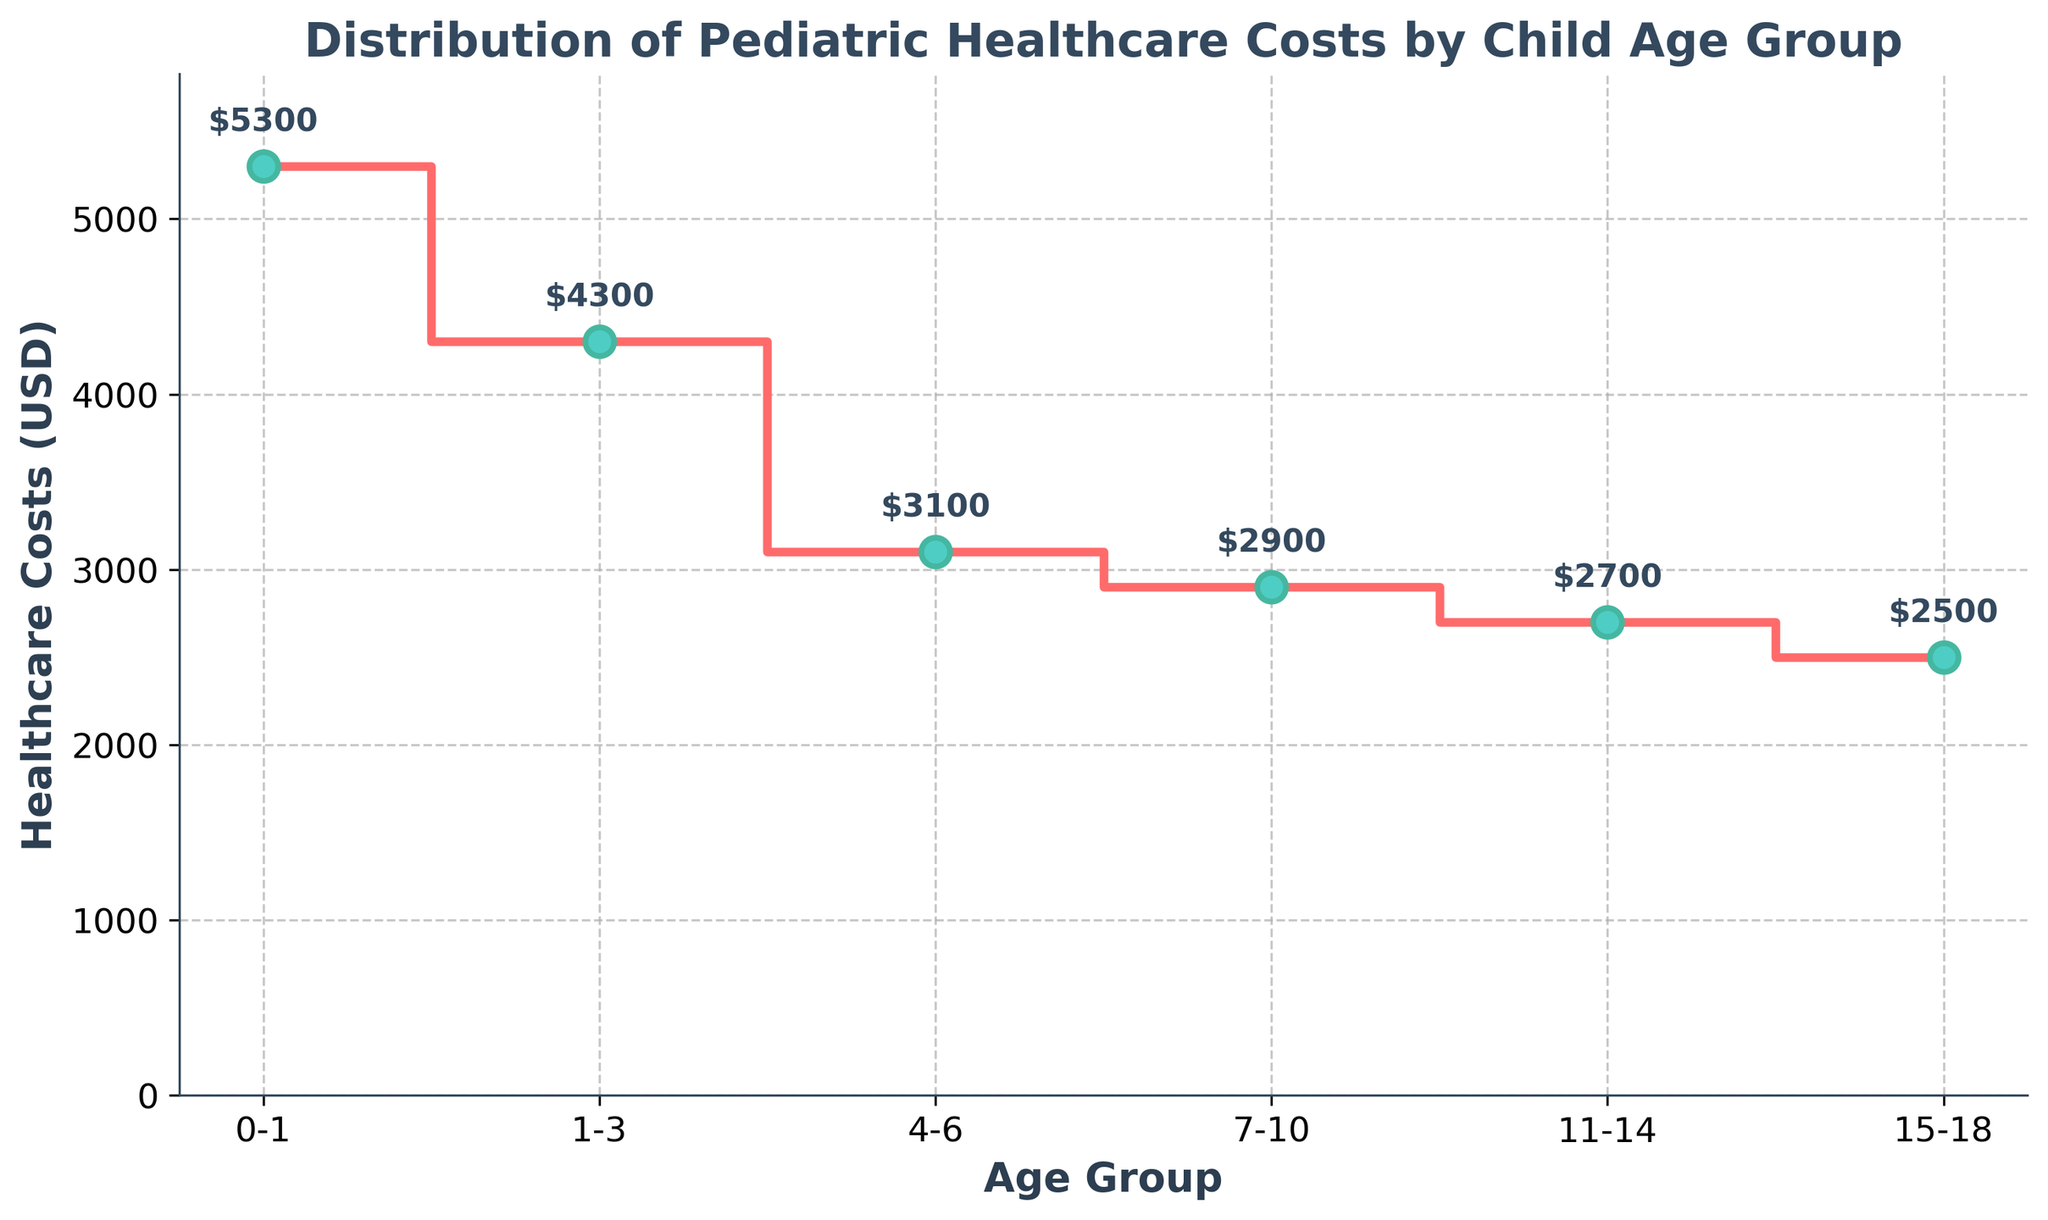What is the title of the plot? The title of the plot appears at the top and provides a concise description of what the plot represents.
Answer: Distribution of Pediatric Healthcare Costs by Child Age Group Which age group has the highest healthcare costs? The highest point on the y-axis that corresponds to an age group on the x-axis indicates the age group with the highest healthcare costs.
Answer: 0-1 What is the healthcare cost for the age group 7-10? Locate the age group 7-10 on the x-axis and trace the corresponding healthcare cost value on the y-axis.
Answer: 2900 How are the healthcare costs between the age groups 1-3 and 15-18 different? Subtract the healthcare cost of the age group 15-18 from the cost of the age group 1-3.
Answer: 1800 What is the average healthcare cost for all the age groups? Sum all the healthcare costs and then divide by the number of age groups, (5300 + 4300 + 3100 + 2900 + 2700 + 2500) / 6.
Answer: 3467 Which age group has the lowest healthcare costs? The lowest point on the y-axis that corresponds to an age group on the x-axis indicates the age group with the lowest healthcare costs.
Answer: 15-18 In which age group range do the healthcare costs start decreasing significantly? Compare the healthcare costs between consecutive age groups to find where the significant drop occurs.
Answer: 0-1 to 1-3 How much do healthcare costs decrease from the age group 4-6 to the age group 11-14? Subtract the healthcare cost of the 11-14 age group from that of the 4-6 age group.
Answer: 400 Do any age groups have equal healthcare costs? Compare the healthcare costs for each age group and check for any matching values.
Answer: No 